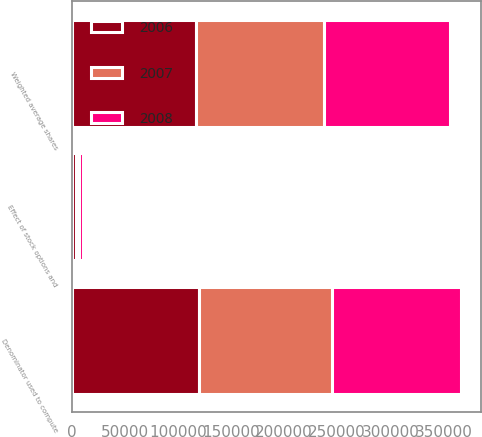Convert chart to OTSL. <chart><loc_0><loc_0><loc_500><loc_500><stacked_bar_chart><ecel><fcel>Weighted average shares<fcel>Effect of stock options and<fcel>Denominator used to compute<nl><fcel>2007<fcel>121083<fcel>3274<fcel>124357<nl><fcel>2008<fcel>118559<fcel>3667<fcel>122226<nl><fcel>2006<fcel>116648<fcel>3725<fcel>120373<nl></chart> 